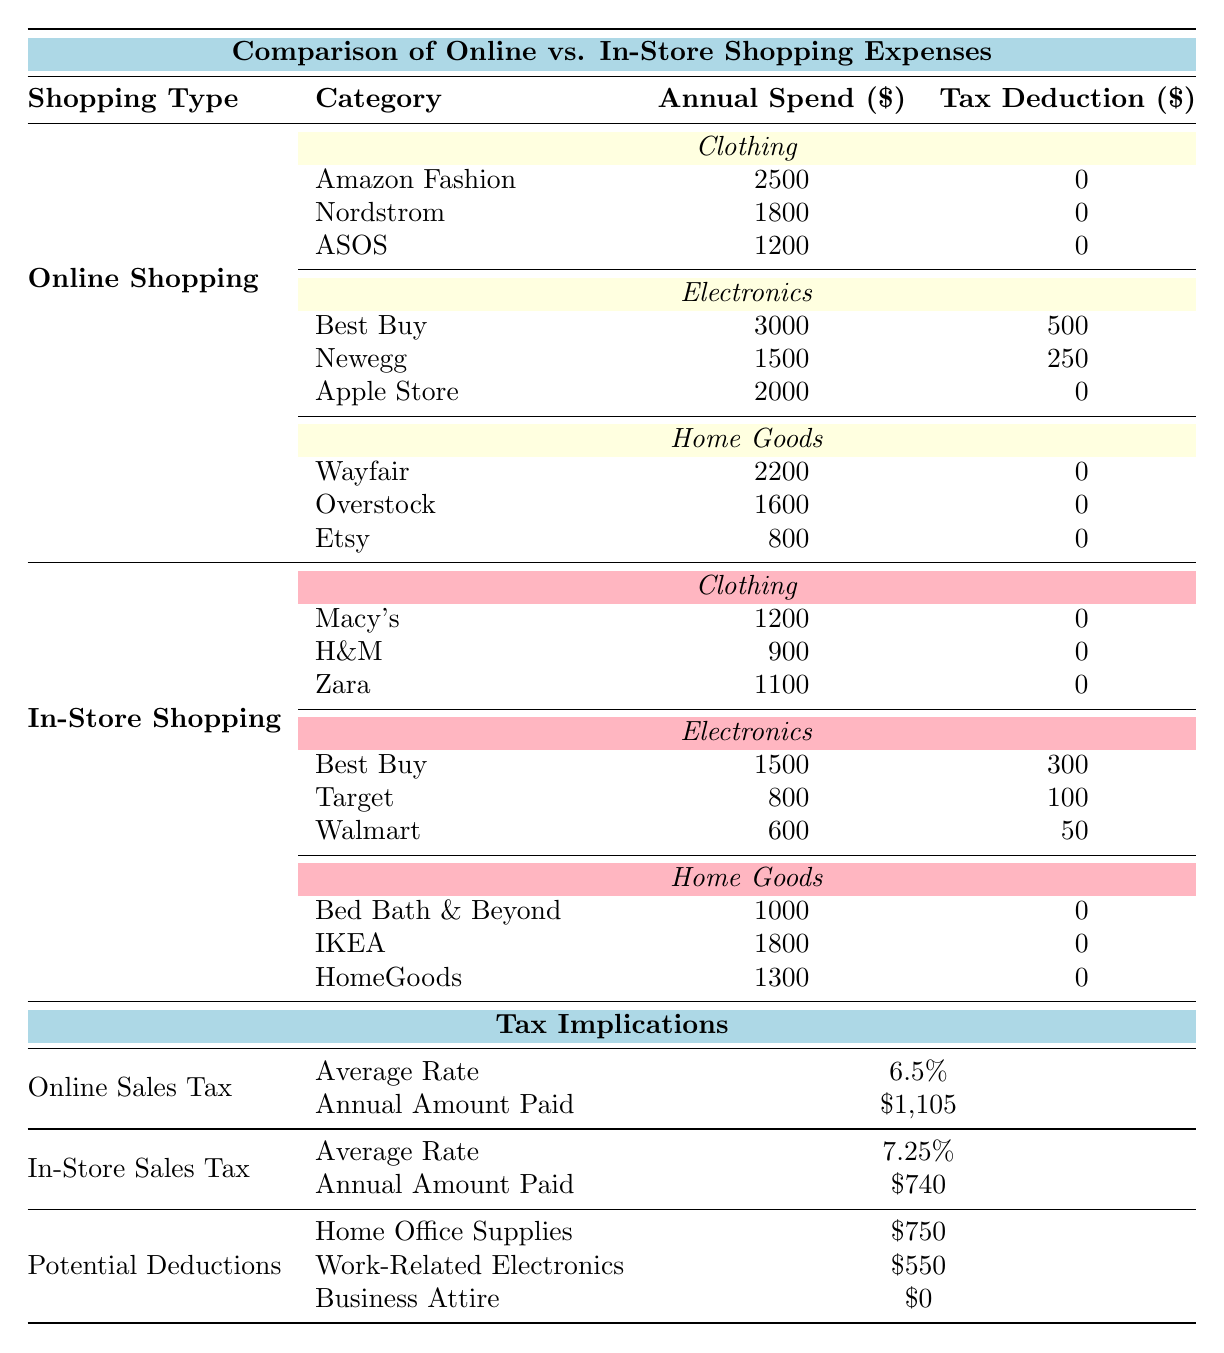What is the total annual spend for online shopping in the electronics category? The electronics category under online shopping includes Best Buy ($3000), Newegg ($1500), and Apple Store ($2000). Adding these values gives $3000 + $1500 + $2000 = $6500.
Answer: $6500 What is the tax deduction amount for Newegg? Looking under the online shopping electronics category, Newegg has a tax deduction of $250 listed next to its annual spend of $1500.
Answer: $250 Is there a tax deduction for online clothing purchases? All entries under the online clothing category (Amazon Fashion, Nordstrom, ASOS) have a tax deduction of $0, indicating that there is no tax deduction for online clothing purchases.
Answer: No Which shopping method has a higher average sales tax rate? Online shopping has an average sales tax rate of 6.5%, while in-store shopping has a rate of 7.25%. Since 7.25% is greater than 6.5%, in-store shopping has a higher average sales tax rate.
Answer: In-store shopping What is the total annual amount spent on clothing for both online and in-store shopping? For online clothing, the total is $2500 (Amazon Fashion) + $1800 (Nordstrom) + $1200 (ASOS) = $5500. For in-store clothing, it is $1200 (Macy's) + $900 (H&M) + $1100 (Zara) = $3200. Adding these totals gives $5500 + $3200 = $8700.
Answer: $8700 What is the average annual spend for 'Home Goods' in online shopping? The total spend for online home goods is $2200 (Wayfair) + $1600 (Overstock) + $800 (Etsy) = $4600. There are three stores, so the average is $4600 / 3 = approximately $1533.33.
Answer: $1533.33 How much is the total potential deduction from all categories provided? The potential deductions listed are $750 (Home Office Supplies), $550 (Work-Related Electronics), and $0 (Business Attire). Adding them gives $750 + $550 + $0 = $1300.
Answer: $1300 Is there a tax deduction for electronics purchases made in-store? The in-store electronics purchases have the following tax deductions: Best Buy has $300, Target has $100, and Walmart has $50. Therefore, not all in-store electronics purchases have a tax deduction, as only some do.
Answer: Yes Which category has the highest annual spend among online shopping options? Looking at each category in online shopping: Clothing totals $5500, Electronics totals $6500, and Home Goods totals $4600. The highest is Electronics with $6500.
Answer: Electronics What is the difference in annual amount paid in sales tax between online and in-store shopping? The annual amount paid for online sales tax is $1105, while for in-store it is $740. The difference is $1105 - $740 = $365.
Answer: $365 Which in-store electronics retailer has the lowest annual spend? Among the in-store electronics retailers: Best Buy has $1500, Target has $800, and Walmart has $600. The lowest annual spend is Walmart with $600.
Answer: Walmart 